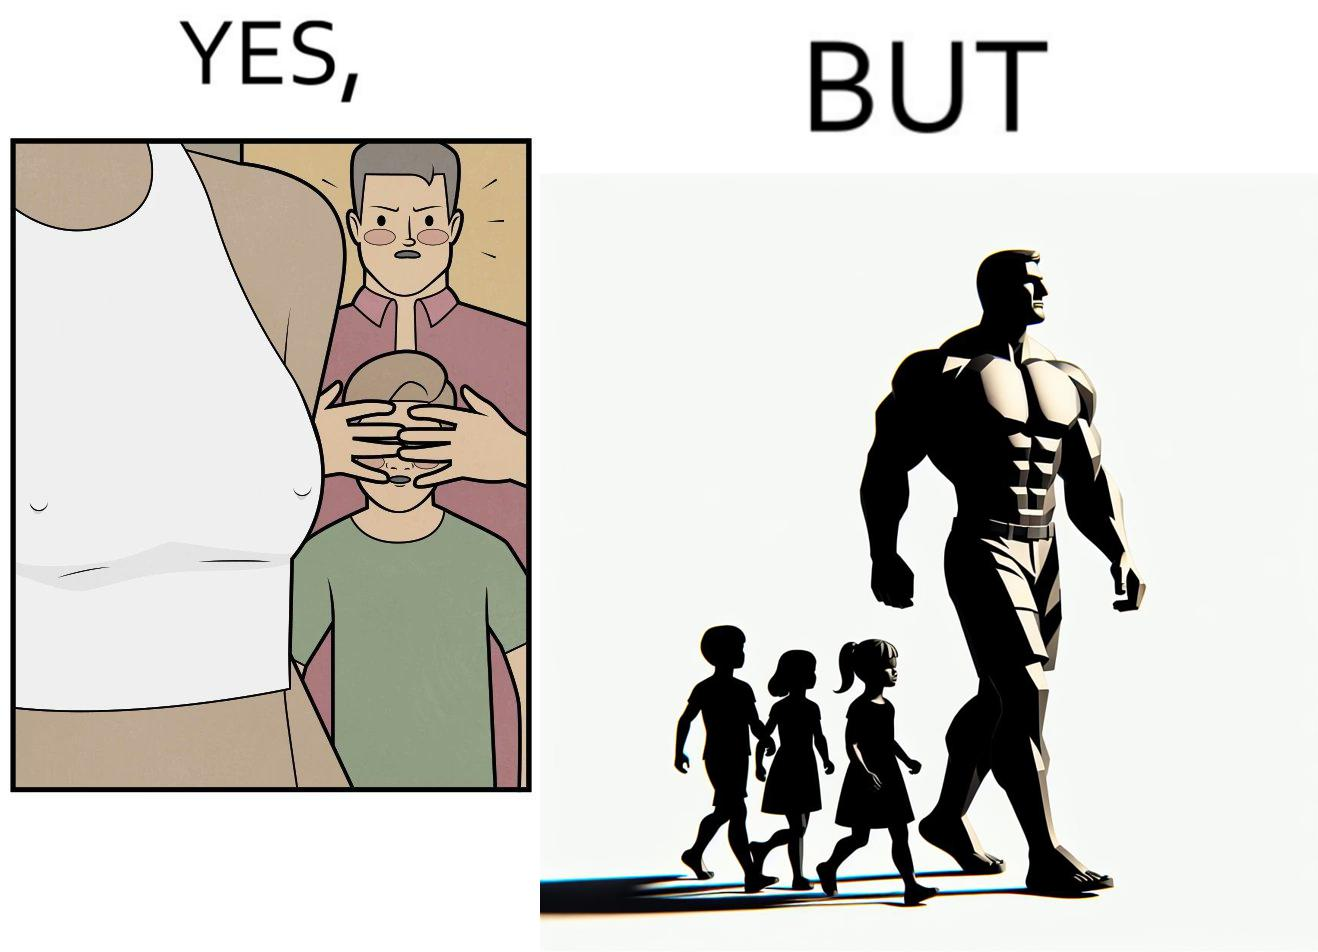Describe what you see in the left and right parts of this image. In the left part of the image: A father is hiding the eyes of his child so that he cannot see the private parts of women. In the right part of the image: The father is roaming with his children in shirt showing his body. 